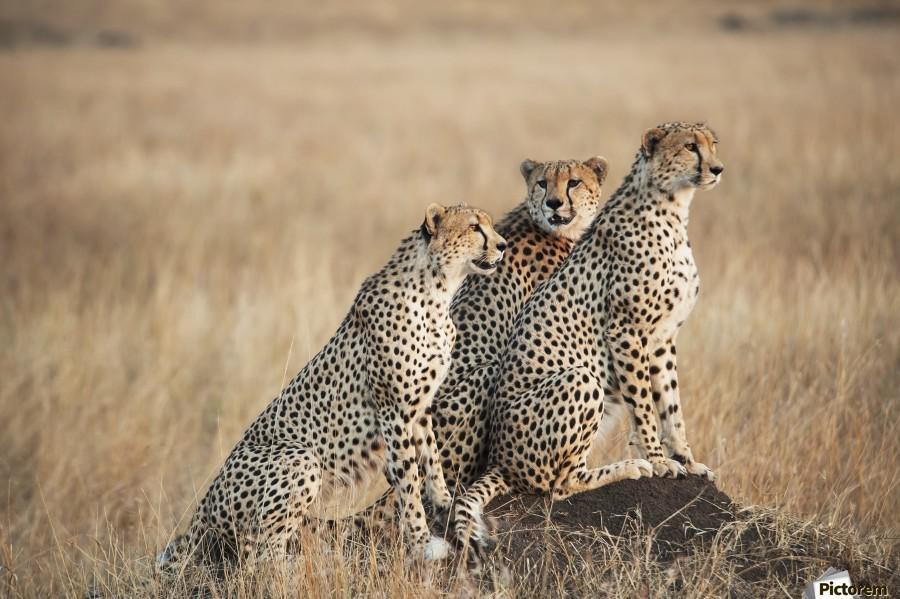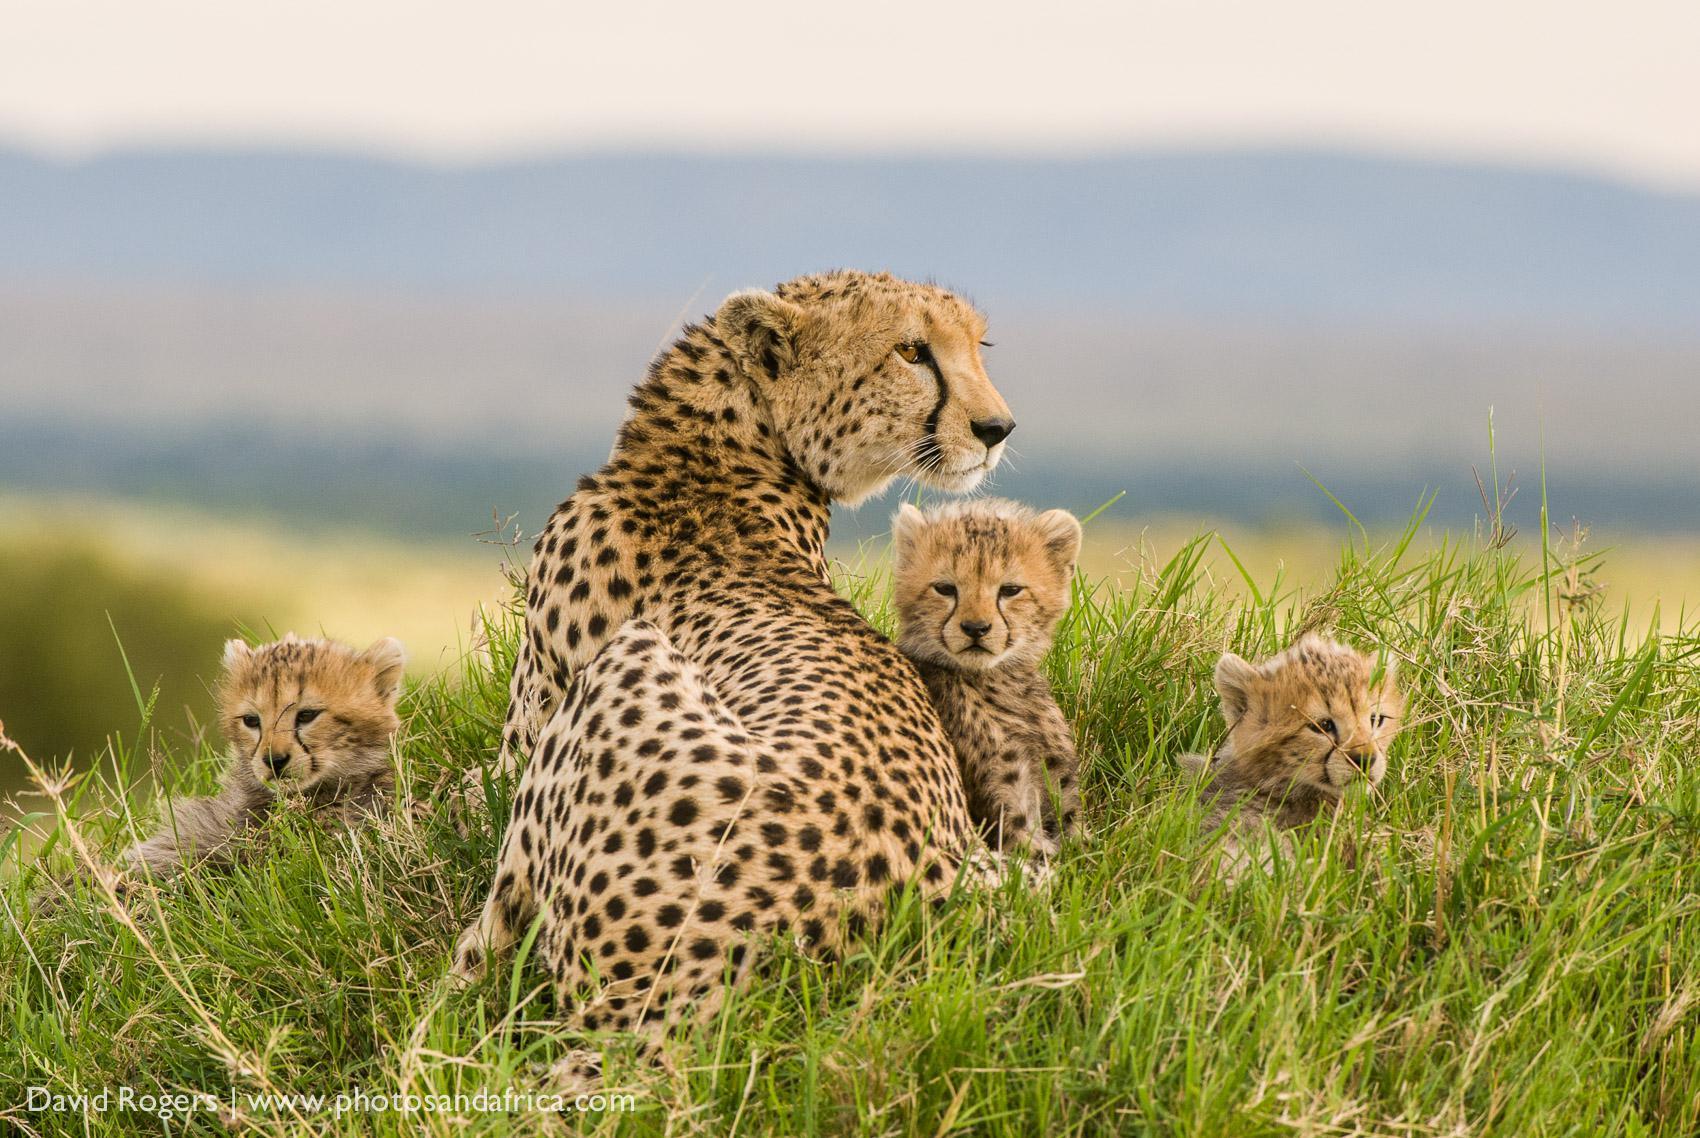The first image is the image on the left, the second image is the image on the right. Assess this claim about the two images: "The right image contains exactly one cheetah.". Correct or not? Answer yes or no. No. The first image is the image on the left, the second image is the image on the right. Analyze the images presented: Is the assertion "The left image contains exactly three cheetahs, and the right image includes an adult cheetah with its back to the camera and its head turned sharply to gaze right." valid? Answer yes or no. Yes. 